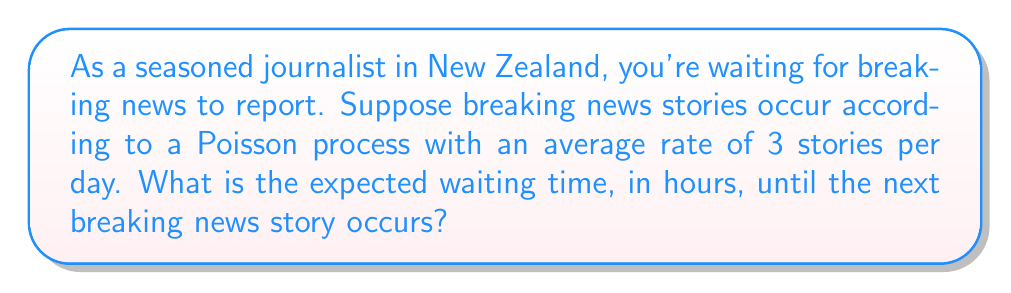Teach me how to tackle this problem. Let's approach this step-by-step:

1) In a Poisson process, the time between events (in this case, breaking news stories) follows an exponential distribution.

2) The parameter of this exponential distribution, let's call it $\lambda$, is the rate of occurrence of the events.

3) We're given that the rate is 3 stories per day. However, we want our answer in hours, so let's convert this:

   $\lambda = 3 \text{ stories/day} = \frac{3}{24} \text{ stories/hour} = 0.125 \text{ stories/hour}$

4) For an exponential distribution, the expected value (mean) is the inverse of the rate parameter:

   $E[X] = \frac{1}{\lambda}$

5) Therefore, the expected waiting time in hours is:

   $E[X] = \frac{1}{0.125} = 8 \text{ hours}$

Thus, on average, you can expect to wait 8 hours for the next breaking news story.
Answer: 8 hours 